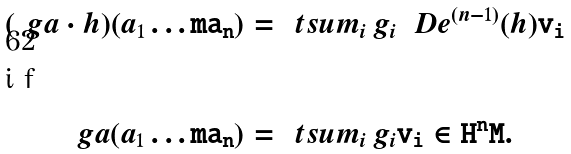Convert formula to latex. <formula><loc_0><loc_0><loc_500><loc_500>( \ g a \cdot h ) ( a _ { 1 } \tt \dots m \tt a _ { n } ) & = \ t s u m _ { i } \, g _ { i } \, \ D e ^ { ( n - 1 ) } ( h ) \tt v _ { i } \intertext { i f } \ g a ( a _ { 1 } \tt \dots m \tt a _ { n } ) & = \ t s u m _ { i } \, g _ { i } \tt v _ { i } \in H ^ { \tt n } \tt M .</formula> 